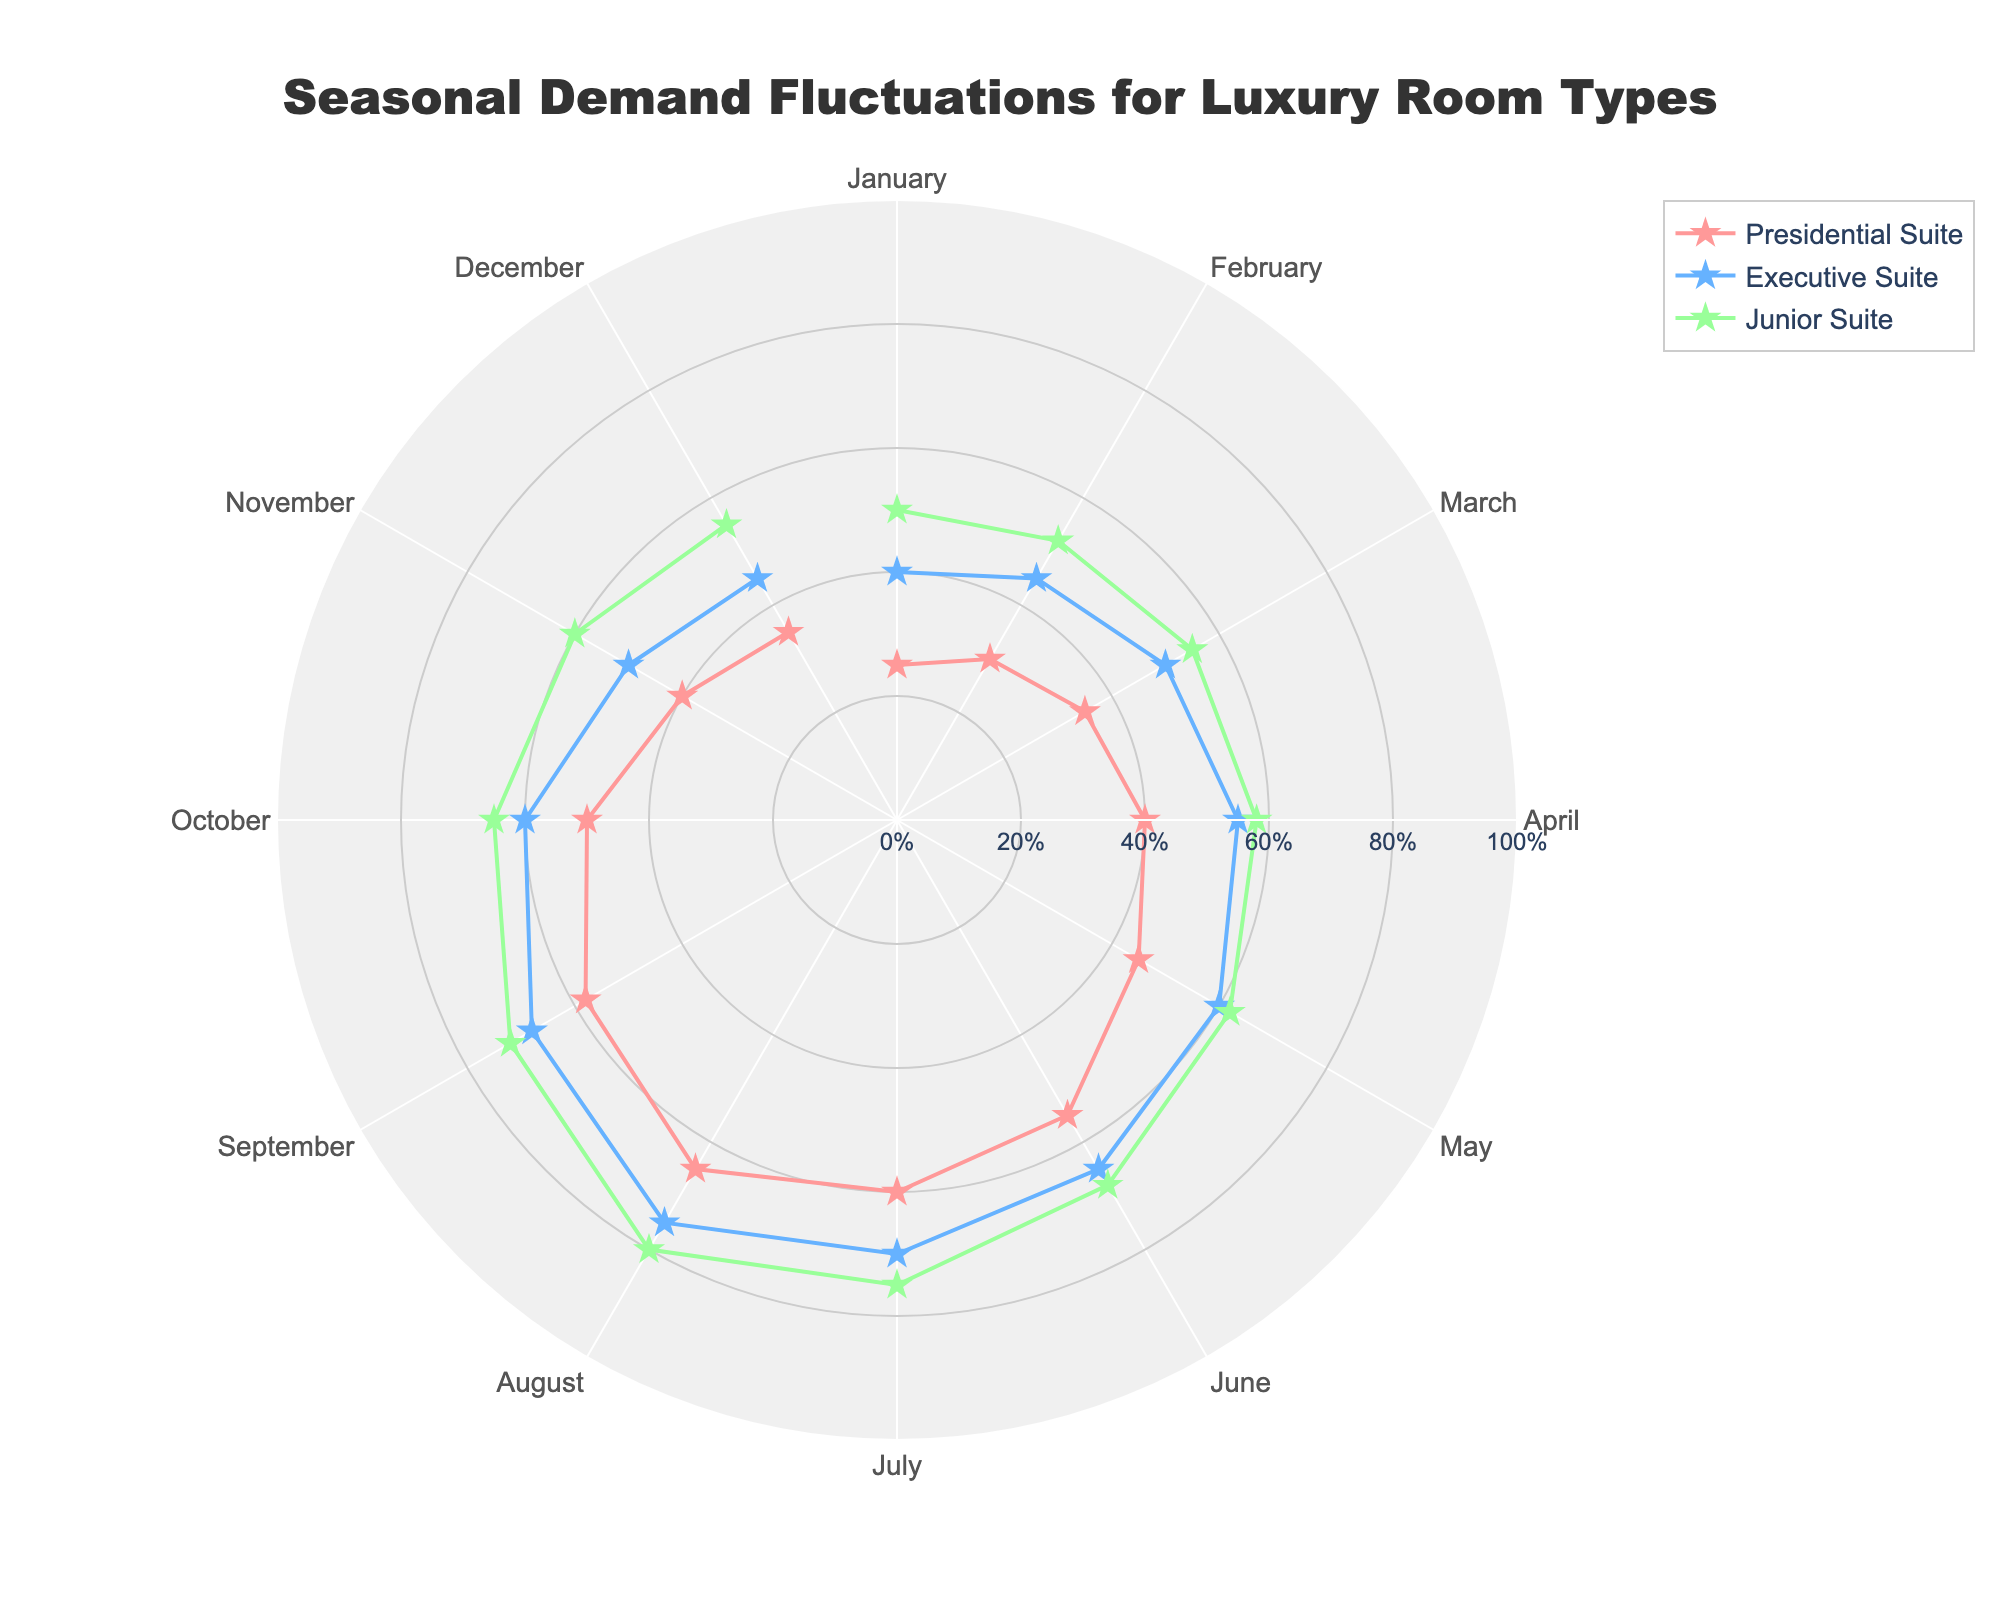What is the title of the figure? The title is written at the top of the figure and reads "Seasonal Demand Fluctuations for Luxury Room Types".
Answer: Seasonal Demand Fluctuations for Luxury Room Types Which room type has the highest occupancy rate in August? In August, the data point towards the outermost point for each room type indicates its occupancy rate. The Junior Suite has the highest rate closest to 1.
Answer: Junior Suite How does the occupancy rate of the Presidential Suite change from January to August? Starting from January, the plot for the Presidential Suite (denoted by one specific color and line) shows a gradual increase each month, reaching its maximum in August.
Answer: It increases Which month shows the highest demand for luxury rooms overall? By observing the spread and extremity of all data points, August has the highest occupancy rates across all room types.
Answer: August Which room type generally has the lowest demand throughout the year? By comparing the proximity of the data points to the center for each room type's line, the Presidential Suite is generally closest to the center, indicating lower occupancy rates.
Answer: Presidential Suite What is the average occupancy rate for the Executive Suite over the year? To find the average, sum the occupancy rates for Executive Suite from January to December and divide by 12. ((0.4 + 0.45 + 0.5 + 0.55 + 0.6 + 0.65 + 0.7 + 0.75 + 0.68 + 0.6 + 0.5 + 0.45) / 12)
Answer: 0.5683 During which months is the occupancy rate for the Junior Suite 0.55 or below? Cross-check the Junior Suite's data points and identify those closest to or below the 0.55 mark on the radial axis. It occurs in January, February, March, December, and November.
Answer: January, February, March, November, and December What is the range of occupancy rates for the Presidential Suite? The range is calculated by subtracting the minimum rate from the maximum rate for the Presidential Suite throughout the year. (0.65 - 0.25)
Answer: 0.4 How does the angular axis (months) rotate in this polar chart? The angular axis starts at January and rotates clockwise through to December.
Answer: Clockwise Which month has the same occupancy rate for all room types? Check for a month where all three room type points align at the same radial distance from the center, which is not observable in this chart (every month has varying rates).
Answer: None 